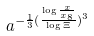Convert formula to latex. <formula><loc_0><loc_0><loc_500><loc_500>a ^ { - \frac { 1 } { 3 } ( \frac { \log \frac { x } { x _ { 8 } } } { \log \Xi } ) ^ { 3 } }</formula> 